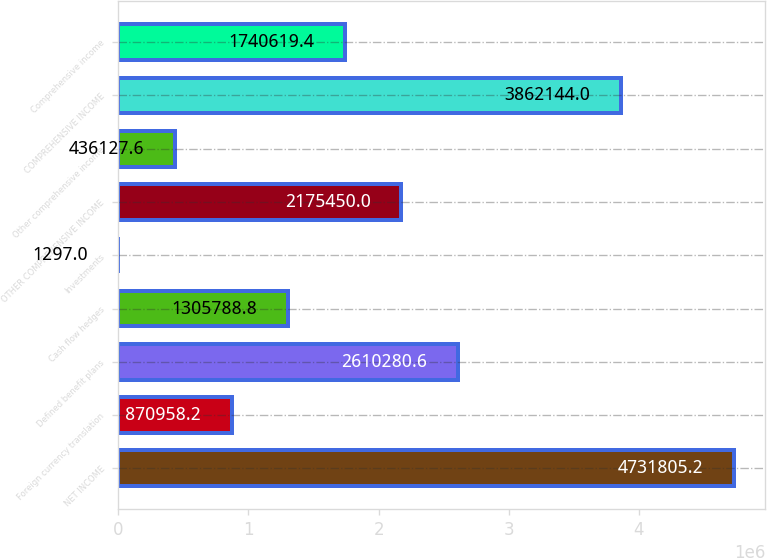Convert chart. <chart><loc_0><loc_0><loc_500><loc_500><bar_chart><fcel>NET INCOME<fcel>Foreign currency translation<fcel>Defined benefit plans<fcel>Cash flow hedges<fcel>Investments<fcel>OTHER COMPREHENSIVE INCOME<fcel>Other comprehensive income<fcel>COMPREHENSIVE INCOME<fcel>Comprehensive income<nl><fcel>4.73181e+06<fcel>870958<fcel>2.61028e+06<fcel>1.30579e+06<fcel>1297<fcel>2.17545e+06<fcel>436128<fcel>3.86214e+06<fcel>1.74062e+06<nl></chart> 